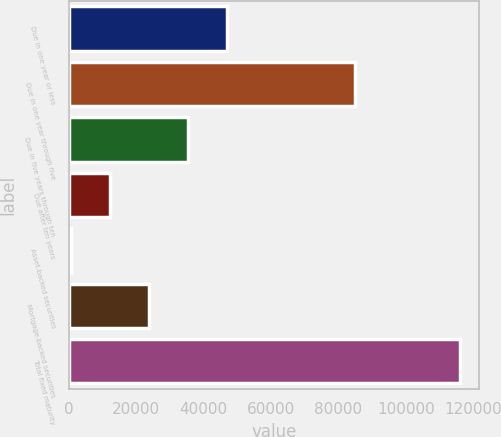Convert chart. <chart><loc_0><loc_0><loc_500><loc_500><bar_chart><fcel>Due in one year or less<fcel>Due in one year through five<fcel>Due in five years through ten<fcel>Due after ten years<fcel>Asset-backed securities<fcel>Mortgage-backed securities<fcel>Total fixed maturity<nl><fcel>46819<fcel>84803<fcel>35294.5<fcel>12245.5<fcel>721<fcel>23770<fcel>115966<nl></chart> 